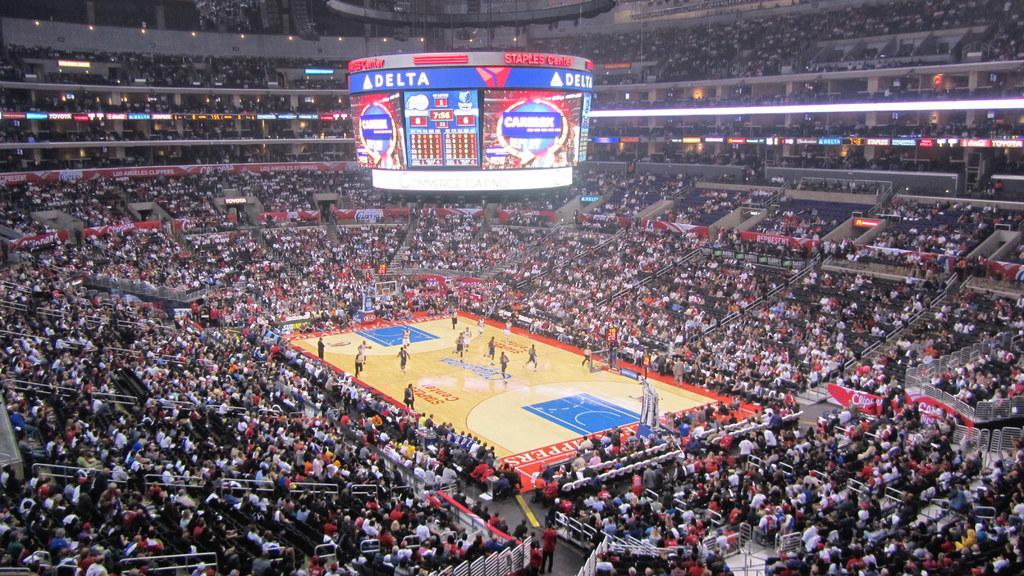Provide a one-sentence caption for the provided image. A basketball game is being played at the Delta arena. 